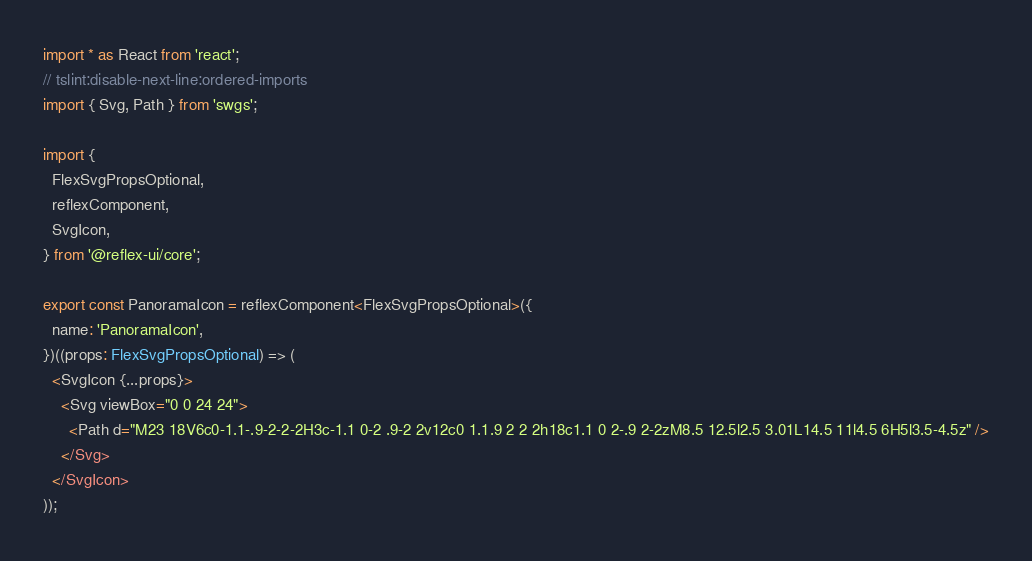Convert code to text. <code><loc_0><loc_0><loc_500><loc_500><_TypeScript_>import * as React from 'react';
// tslint:disable-next-line:ordered-imports
import { Svg, Path } from 'swgs';

import {
  FlexSvgPropsOptional,
  reflexComponent,
  SvgIcon,
} from '@reflex-ui/core';

export const PanoramaIcon = reflexComponent<FlexSvgPropsOptional>({
  name: 'PanoramaIcon',
})((props: FlexSvgPropsOptional) => (
  <SvgIcon {...props}>
    <Svg viewBox="0 0 24 24">
      <Path d="M23 18V6c0-1.1-.9-2-2-2H3c-1.1 0-2 .9-2 2v12c0 1.1.9 2 2 2h18c1.1 0 2-.9 2-2zM8.5 12.5l2.5 3.01L14.5 11l4.5 6H5l3.5-4.5z" />
    </Svg>
  </SvgIcon>
));
</code> 